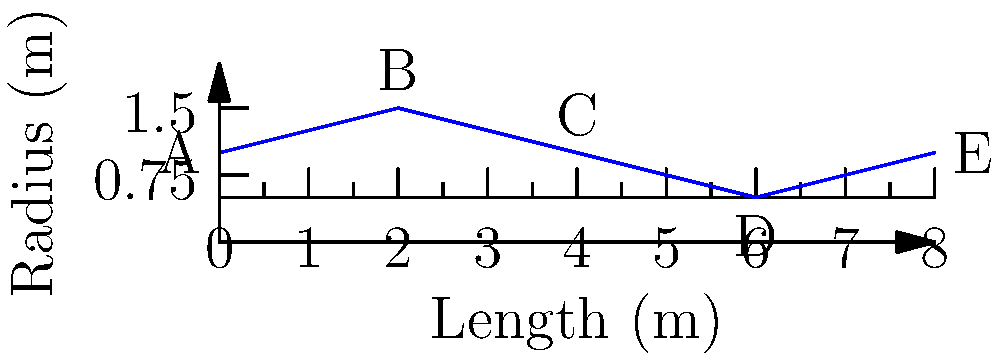A pipe with varying cross-sectional areas is shown in the diagram. The flow is steady and incompressible. If the pressure at point A is 100 kPa and the flow rate is constant throughout the pipe, how would you determine the pressure at point E? Assume no energy losses due to friction. To determine the pressure at point E, we can use Bernoulli's equation and the continuity equation. Here's a step-by-step approach:

1. Apply the continuity equation: $Q = A_1v_1 = A_2v_2 = constant$
   Where $Q$ is the flow rate, $A$ is the cross-sectional area, and $v$ is the velocity.

2. Use Bernoulli's equation between points A and E:
   $P_A + \frac{1}{2}\rho v_A^2 + \rho gh_A = P_E + \frac{1}{2}\rho v_E^2 + \rho gh_E$
   Where $P$ is pressure, $\rho$ is density, $g$ is gravitational acceleration, and $h$ is height.

3. Since the pipe is horizontal, $h_A = h_E$, so these terms cancel out.

4. Express velocities in terms of areas using the continuity equation:
   $v_A = \frac{Q}{A_A}$ and $v_E = \frac{Q}{A_E}$

5. Substitute these into Bernoulli's equation:
   $P_A + \frac{1}{2}\rho (\frac{Q}{A_A})^2 = P_E + \frac{1}{2}\rho (\frac{Q}{A_E})^2$

6. Solve for $P_E$:
   $P_E = P_A + \frac{1}{2}\rho Q^2 (\frac{1}{A_A^2} - \frac{1}{A_E^2})$

7. Given $P_A = 100$ kPa, measure the radii at A and E from the diagram, calculate the areas, and substitute into the equation to find $P_E$.
Answer: $P_E = P_A + \frac{1}{2}\rho Q^2 (\frac{1}{A_A^2} - \frac{1}{A_E^2})$ 